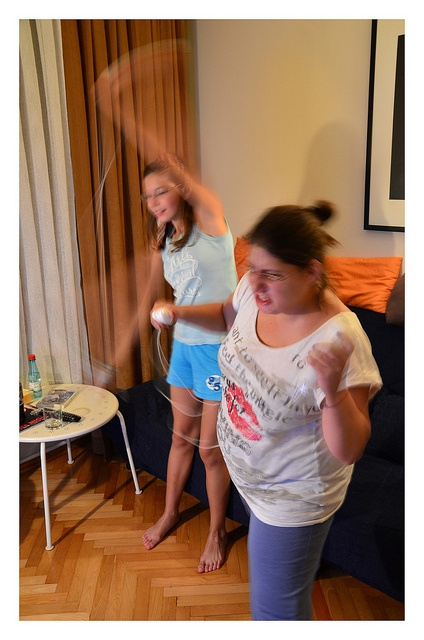Describe the objects in this image and their specific colors. I can see people in white, darkgray, black, maroon, and brown tones, people in white, brown, maroon, and darkgray tones, couch in white, black, red, maroon, and brown tones, dining table in white, tan, and lightgray tones, and remote in white, darkgray, lightgray, and tan tones in this image. 